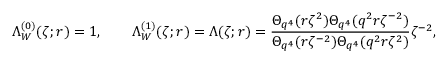Convert formula to latex. <formula><loc_0><loc_0><loc_500><loc_500>\Lambda _ { W } ^ { ( 0 ) } ( \zeta ; r ) = 1 , \quad \Lambda _ { W } ^ { ( 1 ) } ( \zeta ; r ) = \Lambda ( \zeta ; r ) = \frac { \Theta _ { q ^ { 4 } } ( r \zeta ^ { 2 } ) \Theta _ { q ^ { 4 } } ( q ^ { 2 } r \zeta ^ { - 2 } ) } { \Theta _ { q ^ { 4 } } ( r \zeta ^ { - 2 } ) \Theta _ { q ^ { 4 } } ( q ^ { 2 } r \zeta ^ { 2 } ) } \zeta ^ { - 2 } ,</formula> 